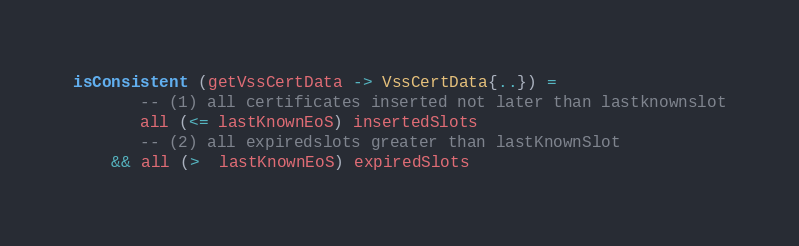<code> <loc_0><loc_0><loc_500><loc_500><_Haskell_>isConsistent (getVssCertData -> VssCertData{..}) =
       -- (1) all certificates inserted not later than lastknownslot
       all (<= lastKnownEoS) insertedSlots
       -- (2) all expiredslots greater than lastKnownSlot
    && all (>  lastKnownEoS) expiredSlots</code> 